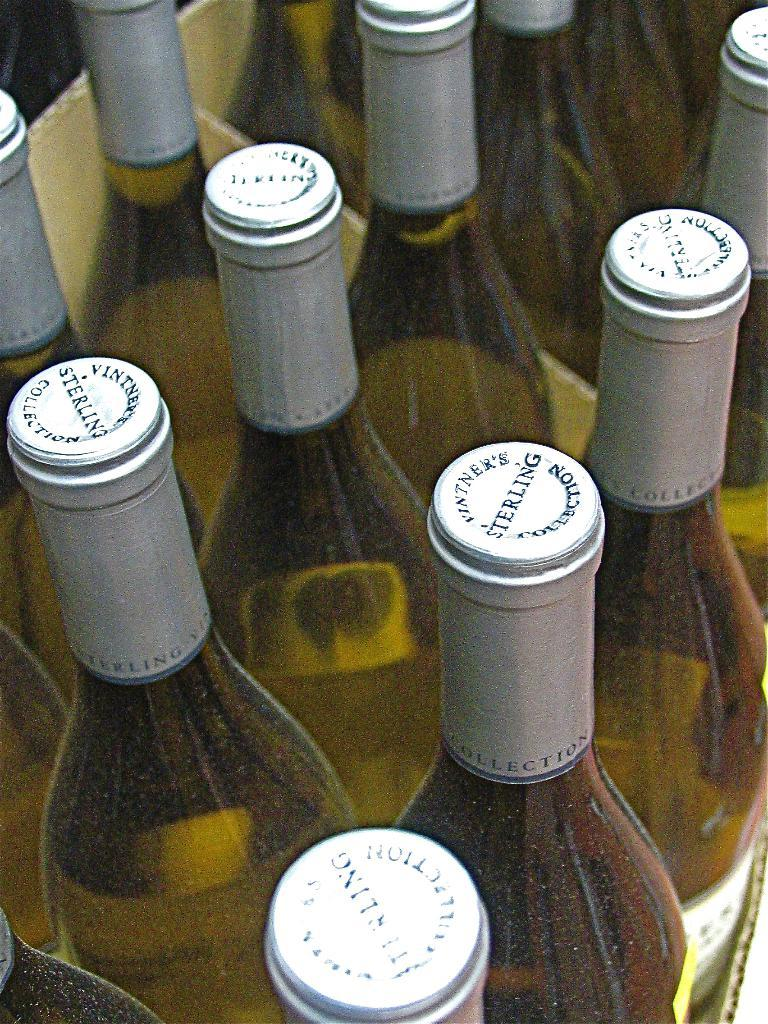<image>
Provide a brief description of the given image. Several bottles of wine line up in rows with the word Sterling on top of the lid. 